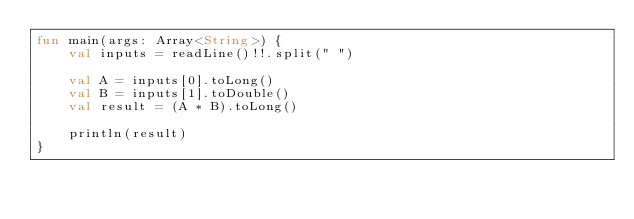Convert code to text. <code><loc_0><loc_0><loc_500><loc_500><_Kotlin_>fun main(args: Array<String>) {
    val inputs = readLine()!!.split(" ")

    val A = inputs[0].toLong()
    val B = inputs[1].toDouble()
    val result = (A * B).toLong()

    println(result)
}
</code> 